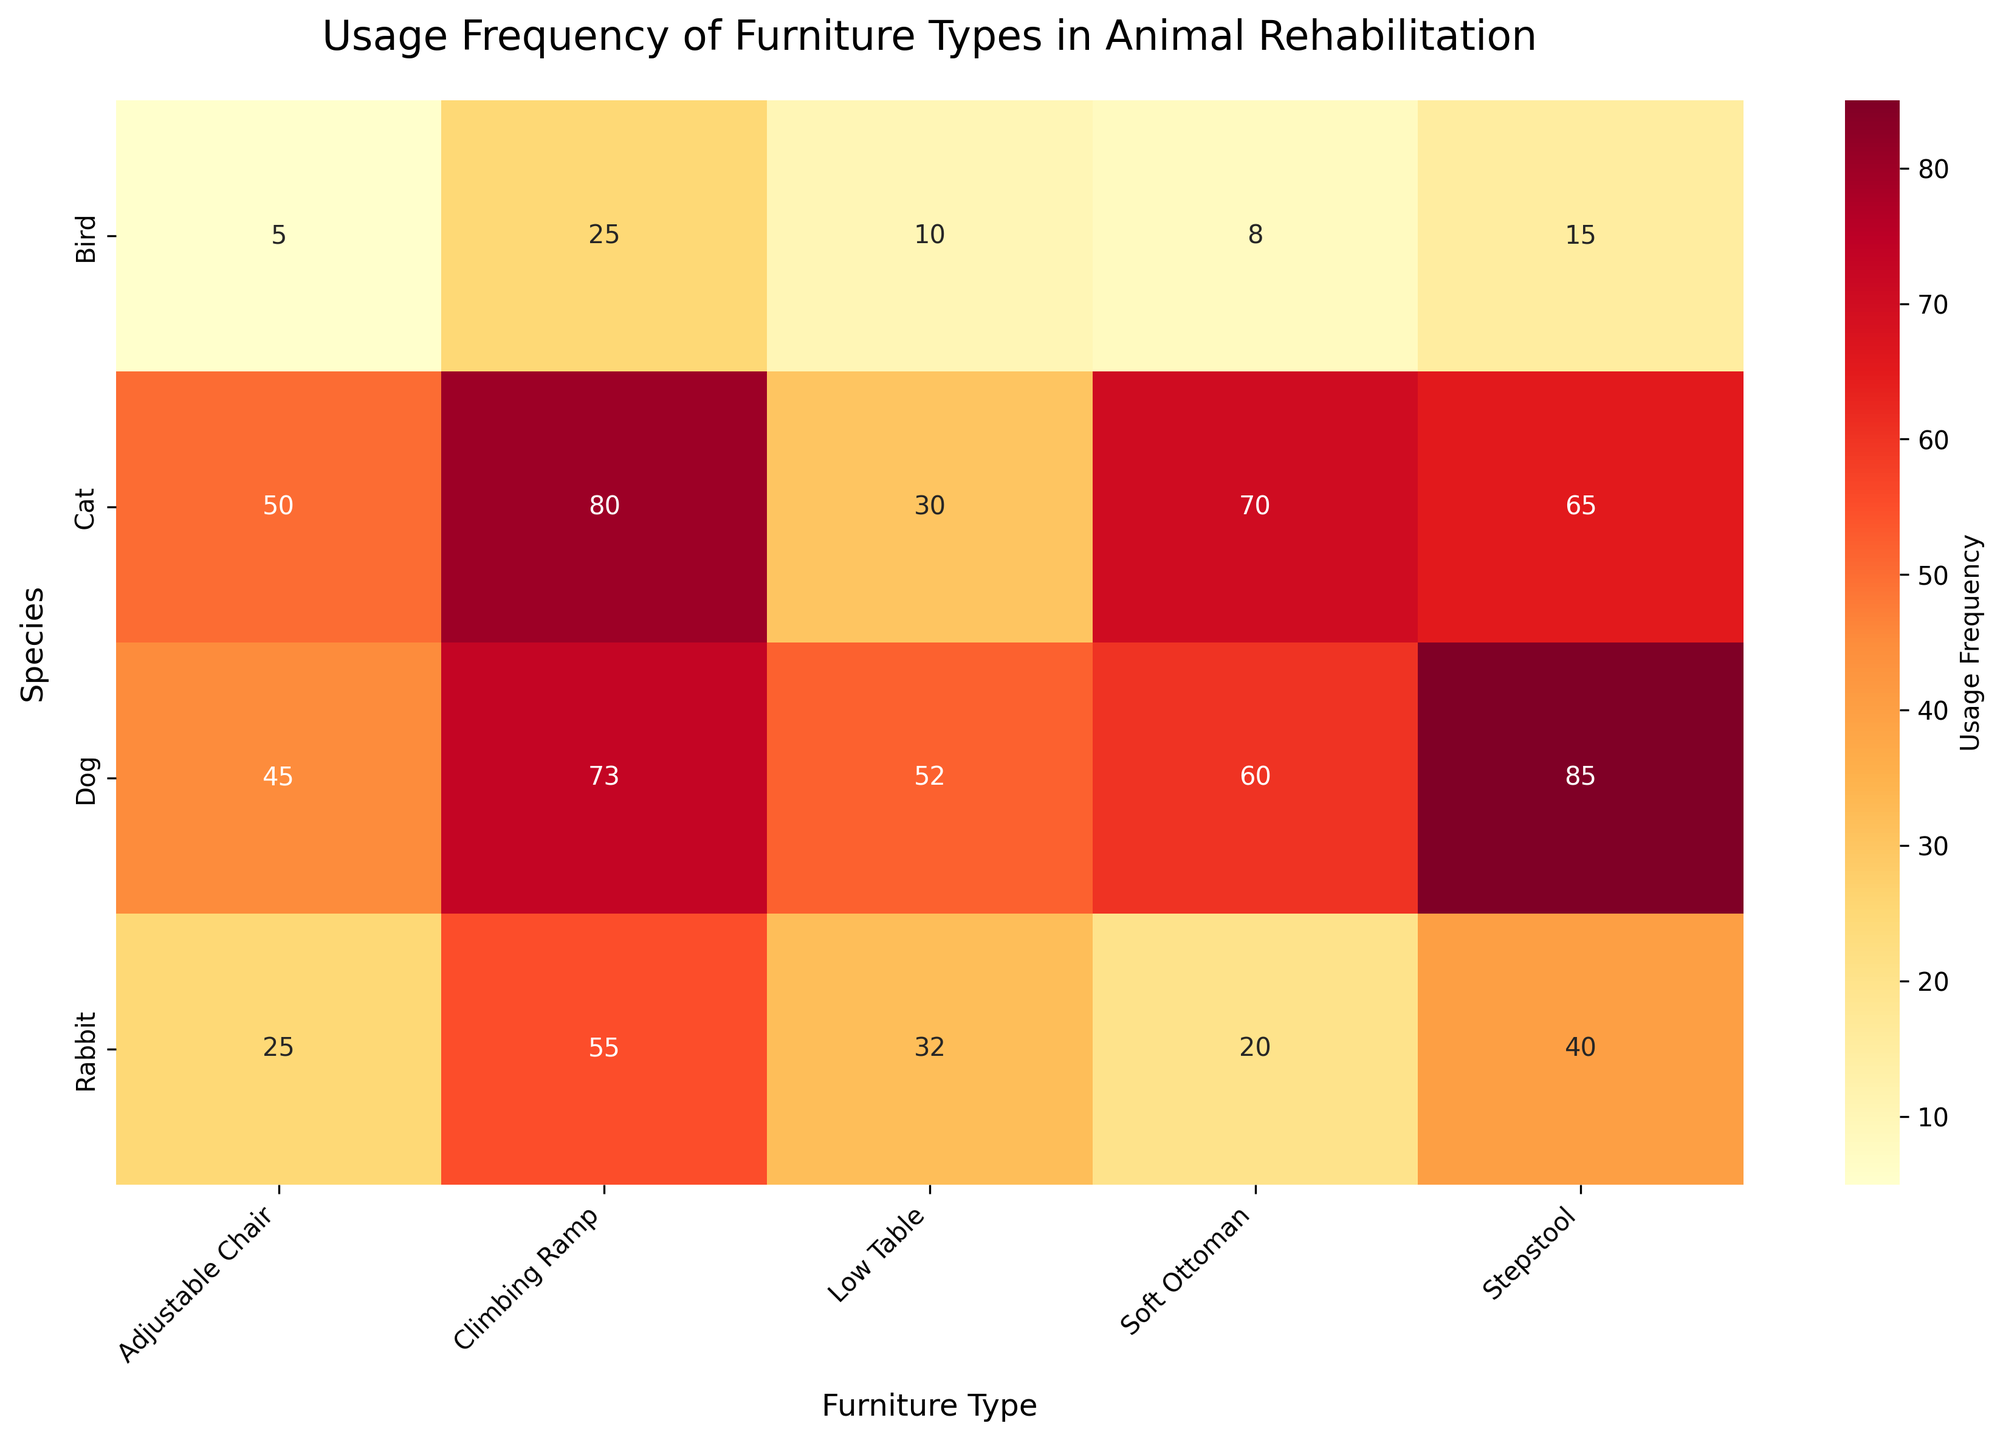What species has the highest usage frequency of the Stepstool? First, locate the column labeled "Stepstool". Find the maximum value in this column, which is 85 for Dogs.
Answer: Dog Which furniture type has the lowest usage frequency for Birds? Check the row labeled "Bird" and identify the lowest value. The lowest value is 5 for the Adjustable Chair.
Answer: Adjustable Chair What is the total usage frequency of Low Table for all species combined? Sum up the usage frequencies for Low Table across all species (52+30+32+10=124).
Answer: 124 How does the usage frequency of the Soft Ottoman for Cats compare to that for Rabbits? Compare the values in the Soft Ottoman column for Cats (70) and Rabbits (20). Cats use it more frequently.
Answer: Cats use it more Which species shows the most balanced usage across all furniture types? Look for the row where the values do not vary dramatically. Cats have values ranging from 30 to 80, which shows more balance compared to other species.
Answer: Cat What is the difference in usage frequency of Climbing Ramp between Dogs and Rabbits? Subtract the usage frequency for Rabbits (55) from that for Dogs (73). The difference is 18.
Answer: 18 Which furniture type is used almost equally by both Dogs and Cats? Compare the values of each furniture type for Dogs and Cats. The Adjustable Chair has similar values (45 and 50, respectively).
Answer: Adjustable Chair What is the average usage frequency of furniture types by Birds? Add up the usage frequencies for Birds (15+25+5+10+8=63) and divide by the number of types (5). Average = 63/5 = 12.6.
Answer: 12.6 How much more is the usage frequency of Climbing Ramp compared to Low Table for Cats? Subtract the Low Table usage frequency (30) from the Climbing Ramp usage frequency (80). The result is 50.
Answer: 50 